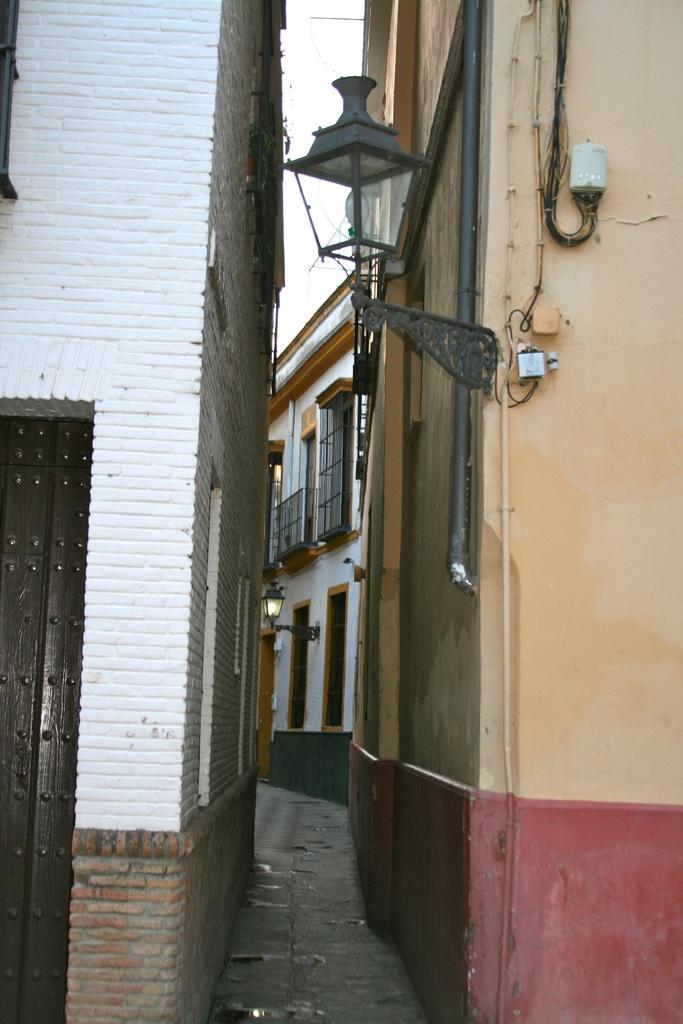Please provide a concise description of this image. In this image we can see buildings and there is a light. In the background we can see sky. 